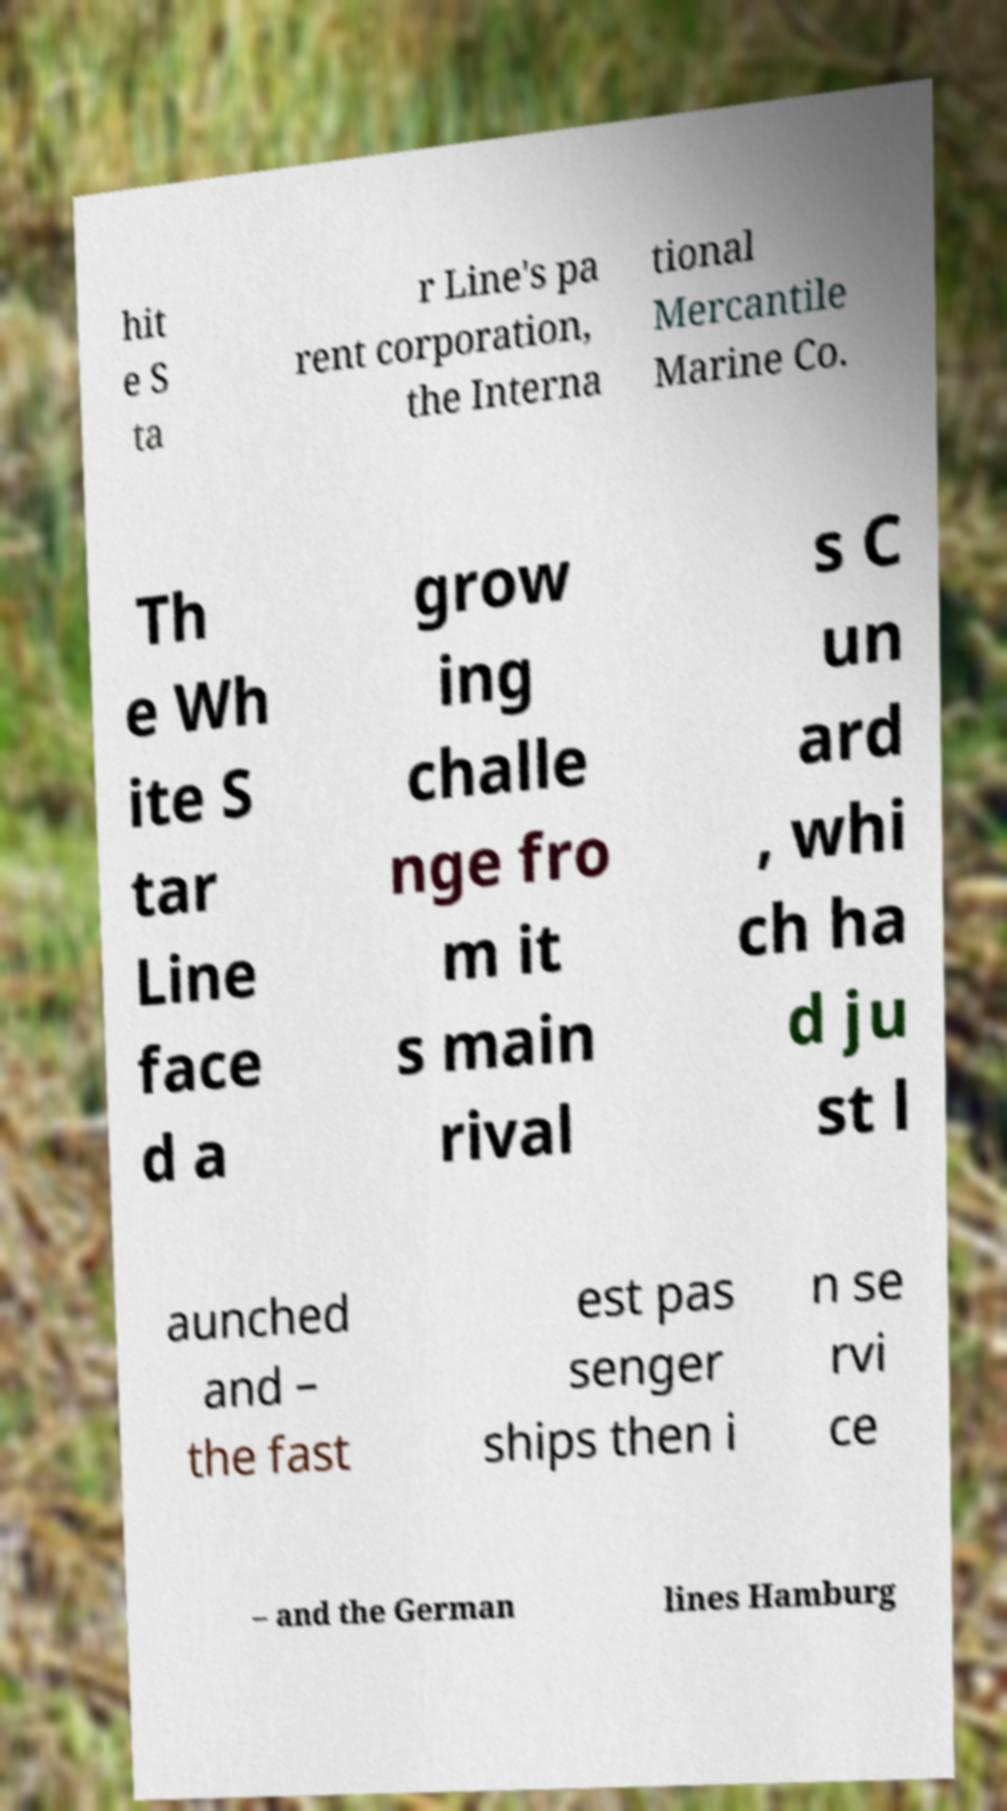Can you read and provide the text displayed in the image?This photo seems to have some interesting text. Can you extract and type it out for me? hit e S ta r Line's pa rent corporation, the Interna tional Mercantile Marine Co. Th e Wh ite S tar Line face d a grow ing challe nge fro m it s main rival s C un ard , whi ch ha d ju st l aunched and – the fast est pas senger ships then i n se rvi ce – and the German lines Hamburg 